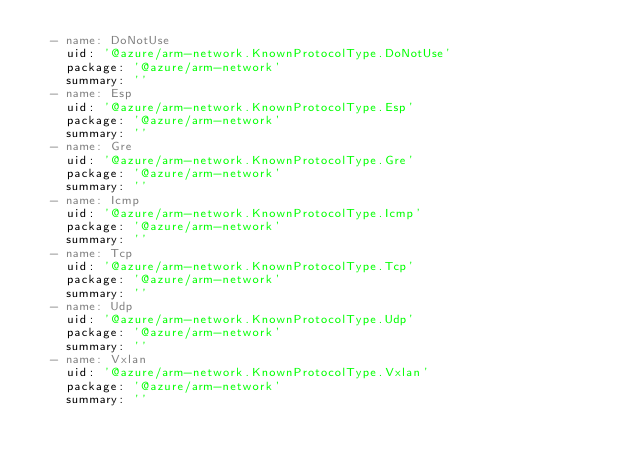Convert code to text. <code><loc_0><loc_0><loc_500><loc_500><_YAML_>  - name: DoNotUse
    uid: '@azure/arm-network.KnownProtocolType.DoNotUse'
    package: '@azure/arm-network'
    summary: ''
  - name: Esp
    uid: '@azure/arm-network.KnownProtocolType.Esp'
    package: '@azure/arm-network'
    summary: ''
  - name: Gre
    uid: '@azure/arm-network.KnownProtocolType.Gre'
    package: '@azure/arm-network'
    summary: ''
  - name: Icmp
    uid: '@azure/arm-network.KnownProtocolType.Icmp'
    package: '@azure/arm-network'
    summary: ''
  - name: Tcp
    uid: '@azure/arm-network.KnownProtocolType.Tcp'
    package: '@azure/arm-network'
    summary: ''
  - name: Udp
    uid: '@azure/arm-network.KnownProtocolType.Udp'
    package: '@azure/arm-network'
    summary: ''
  - name: Vxlan
    uid: '@azure/arm-network.KnownProtocolType.Vxlan'
    package: '@azure/arm-network'
    summary: ''
</code> 